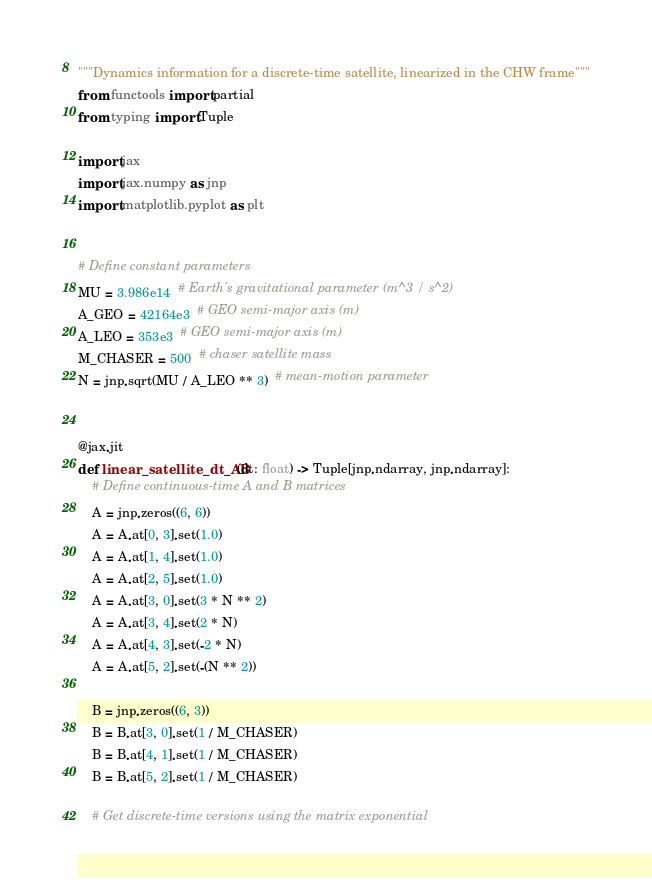Convert code to text. <code><loc_0><loc_0><loc_500><loc_500><_Python_>"""Dynamics information for a discrete-time satellite, linearized in the CHW frame"""
from functools import partial
from typing import Tuple

import jax
import jax.numpy as jnp
import matplotlib.pyplot as plt


# Define constant parameters
MU = 3.986e14  # Earth's gravitational parameter (m^3 / s^2)
A_GEO = 42164e3  # GEO semi-major axis (m)
A_LEO = 353e3  # GEO semi-major axis (m)
M_CHASER = 500  # chaser satellite mass
N = jnp.sqrt(MU / A_LEO ** 3)  # mean-motion parameter


@jax.jit
def linear_satellite_dt_AB(dt: float) -> Tuple[jnp.ndarray, jnp.ndarray]:
    # Define continuous-time A and B matrices
    A = jnp.zeros((6, 6))
    A = A.at[0, 3].set(1.0)
    A = A.at[1, 4].set(1.0)
    A = A.at[2, 5].set(1.0)
    A = A.at[3, 0].set(3 * N ** 2)
    A = A.at[3, 4].set(2 * N)
    A = A.at[4, 3].set(-2 * N)
    A = A.at[5, 2].set(-(N ** 2))

    B = jnp.zeros((6, 3))
    B = B.at[3, 0].set(1 / M_CHASER)
    B = B.at[4, 1].set(1 / M_CHASER)
    B = B.at[5, 2].set(1 / M_CHASER)

    # Get discrete-time versions using the matrix exponential</code> 